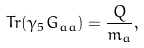<formula> <loc_0><loc_0><loc_500><loc_500>T r ( \gamma _ { 5 } G _ { a a } ) = \frac { Q } { m _ { a } } ,</formula> 